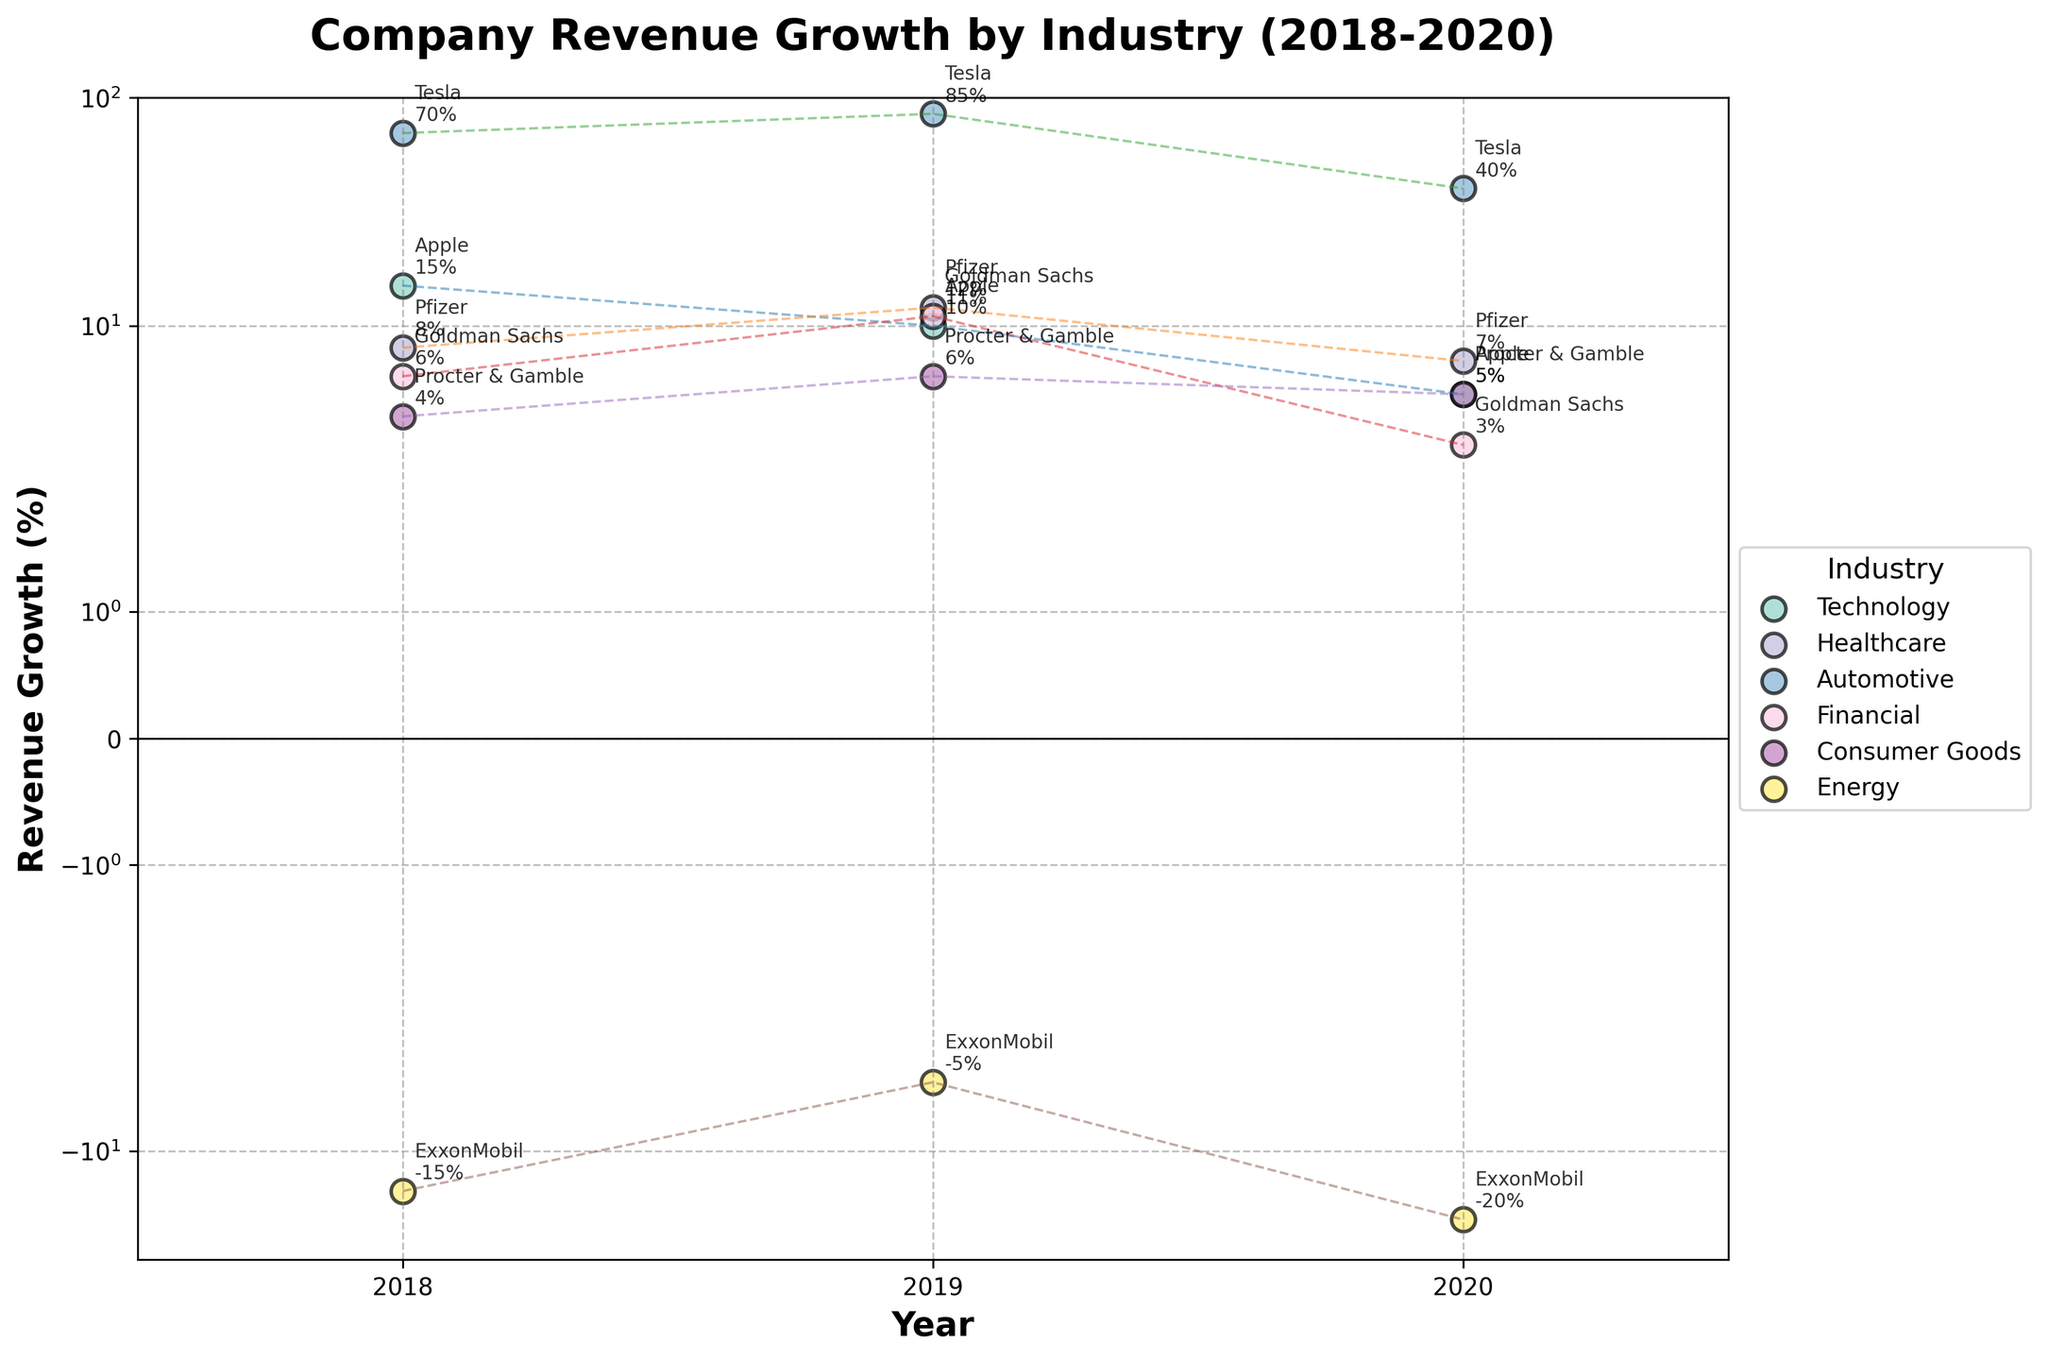What is the title of the scatter plot? The title of the plot is displayed at the top of the figure, often in a larger and bold font.
Answer: Company Revenue Growth by Industry (2018-2020) Which axis represents the revenue growth percentage? The axis is labeled with "Revenue Growth (%)", which indicates it is the y-axis.
Answer: y-axis What are the industries included in the plot? The unique industries can be identified by looking at the legend.
Answer: Technology, Healthcare, Automotive, Financial, Consumer Goods, Energy Which company had the highest revenue growth in 2019? Locate 2019 on the x-axis and find the highest data point on the y-axis for that year. The annotation and legend indicate the company and its industry.
Answer: Tesla How did Pfizer's revenue growth change from 2018 to 2020? Locate Pfizer's data points and annotations for each year and compare the values.
Answer: Increased from 8% in 2018 to 12% in 2019, then decreased to 7% in 2020 In which year did ExxonMobil have the lowest revenue growth? Locate the data points for ExxonMobil and find the smallest value on the y-axis.
Answer: 2020 Which industry had the most consistent revenue growth trend from 2018 to 2020? Compare the lines connecting data points for each industry; the most consistent trend should have the least variation.
Answer: Consumer Goods What is the average revenue growth for Apple over the years displayed? Add the revenue growth values for Apple over the three years (15%, 10%, 5%) and divide by the number of years, 3.
Answer: 10% Which company showed a negative revenue growth in any year? Check the y-axis below 0 and identify the companies associated with these data points.
Answer: ExxonMobil In 2020, which company had the highest revenue growth, and what was the percentage? Locate the 2020 data points and find the highest one. The annotation or legend will indicate the company and its industry.
Answer: Tesla, 40% 